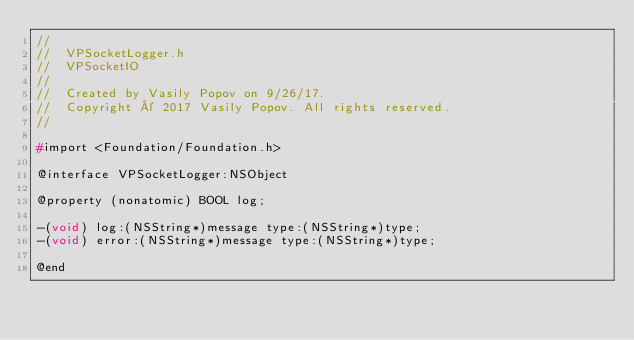Convert code to text. <code><loc_0><loc_0><loc_500><loc_500><_C_>//
//  VPSocketLogger.h
//  VPSocketIO
//
//  Created by Vasily Popov on 9/26/17.
//  Copyright © 2017 Vasily Popov. All rights reserved.
//

#import <Foundation/Foundation.h>

@interface VPSocketLogger:NSObject

@property (nonatomic) BOOL log;

-(void) log:(NSString*)message type:(NSString*)type;
-(void) error:(NSString*)message type:(NSString*)type;

@end
</code> 